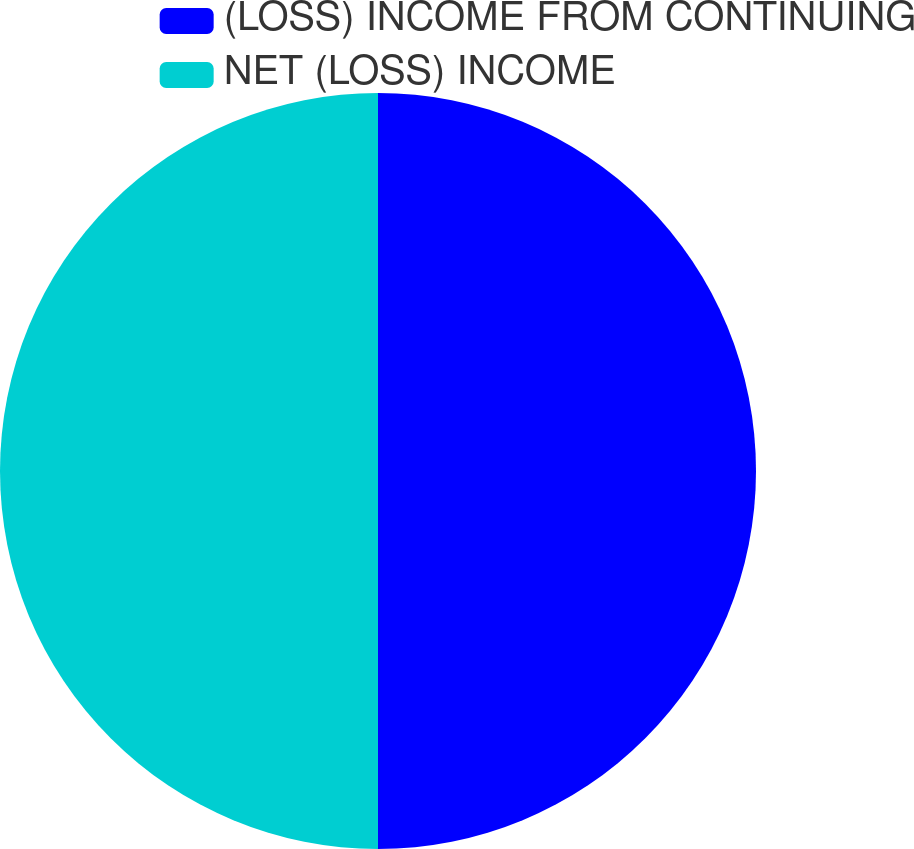Convert chart. <chart><loc_0><loc_0><loc_500><loc_500><pie_chart><fcel>(LOSS) INCOME FROM CONTINUING<fcel>NET (LOSS) INCOME<nl><fcel>50.0%<fcel>50.0%<nl></chart> 